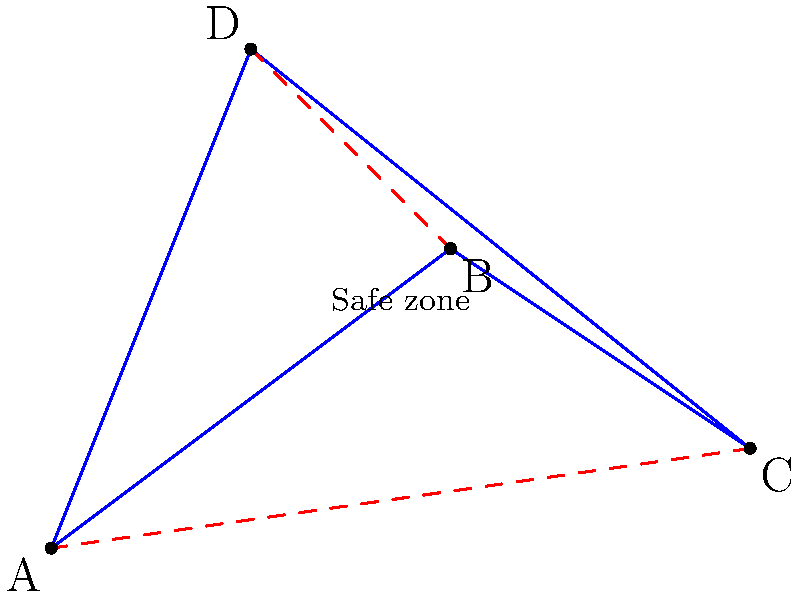As a concerned parent planning a safe route for your child's school field trip, you need to determine the shortest path that connects all four checkpoints (A, B, C, and D) while avoiding potential hazards. Given the coordinates of the checkpoints A(0,0), B(4,3), C(7,1), and D(2,5), calculate the total distance of the shortest path that visits all points exactly once and returns to the starting point. Which path should you recommend to ensure both efficiency and safety? To solve this problem, we'll use the distance formula and compare the possible paths:

1. Distance formula: $d = \sqrt{(x_2-x_1)^2 + (y_2-y_1)^2}$

2. Calculate distances between all points:
   AB = $\sqrt{(4-0)^2 + (3-0)^2} = 5$
   BC = $\sqrt{(7-4)^2 + (1-3)^2} = \sqrt{13} \approx 3.61$
   CD = $\sqrt{(2-7)^2 + (5-1)^2} = \sqrt{41} \approx 6.40$
   DA = $\sqrt{(0-2)^2 + (0-5)^2} = \sqrt{29} \approx 5.39$
   AC = $\sqrt{(7-0)^2 + (1-0)^2} = \sqrt{50} \approx 7.07$
   BD = $\sqrt{(2-4)^2 + (5-3)^2} = \sqrt{8} \approx 2.83$

3. Possible paths:
   A-B-C-D-A: 5 + 3.61 + 6.40 + 5.39 = 20.40
   A-B-D-C-A: 5 + 2.83 + 6.40 + 7.07 = 21.30
   A-C-B-D-A: 7.07 + 3.61 + 2.83 + 5.39 = 18.90
   A-C-D-B-A: 7.07 + 6.40 + 2.83 + 5 = 21.30
   A-D-B-C-A: 5.39 + 2.83 + 3.61 + 7.07 = 18.90
   A-D-C-B-A: 5.39 + 6.40 + 3.61 + 5 = 20.40

4. The shortest paths are A-C-B-D-A and A-D-B-C-A, both with a total distance of 18.90 units.

5. For safety, we should consider that the path A-C-B-D-A crosses itself, which might be less safe than A-D-B-C-A.

Therefore, the recommended path for both efficiency and safety is A-D-B-C-A.
Answer: A-D-B-C-A, total distance 18.90 units 